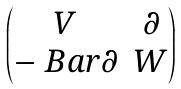Convert formula to latex. <formula><loc_0><loc_0><loc_500><loc_500>\begin{pmatrix} V & \partial \\ - \ B a r { \partial } & W \end{pmatrix}</formula> 